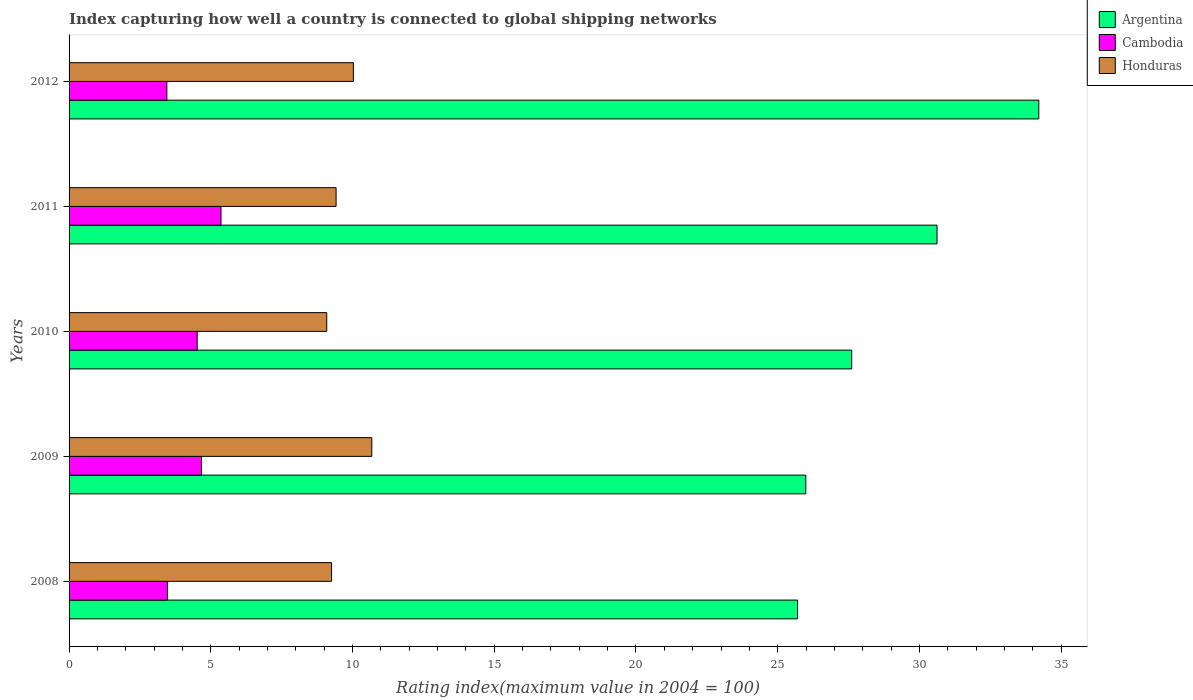Are the number of bars on each tick of the Y-axis equal?
Provide a succinct answer. Yes. How many bars are there on the 2nd tick from the top?
Your response must be concise. 3. What is the label of the 3rd group of bars from the top?
Provide a short and direct response. 2010. What is the rating index in Argentina in 2008?
Your response must be concise. 25.7. Across all years, what is the maximum rating index in Honduras?
Offer a very short reply. 10.68. Across all years, what is the minimum rating index in Honduras?
Keep it short and to the point. 9.09. What is the total rating index in Cambodia in the graph?
Offer a very short reply. 21.47. What is the difference between the rating index in Argentina in 2008 and that in 2010?
Make the answer very short. -1.91. What is the difference between the rating index in Argentina in 2010 and the rating index in Cambodia in 2009?
Give a very brief answer. 22.94. What is the average rating index in Cambodia per year?
Your answer should be very brief. 4.29. In the year 2009, what is the difference between the rating index in Cambodia and rating index in Honduras?
Provide a short and direct response. -6.01. In how many years, is the rating index in Argentina greater than 27 ?
Provide a short and direct response. 3. What is the ratio of the rating index in Honduras in 2009 to that in 2012?
Offer a very short reply. 1.06. What is the difference between the highest and the second highest rating index in Honduras?
Give a very brief answer. 0.65. What is the difference between the highest and the lowest rating index in Argentina?
Offer a terse response. 8.51. What does the 1st bar from the top in 2009 represents?
Provide a succinct answer. Honduras. How many bars are there?
Offer a terse response. 15. Are all the bars in the graph horizontal?
Provide a succinct answer. Yes. What is the difference between two consecutive major ticks on the X-axis?
Your response must be concise. 5. Does the graph contain grids?
Ensure brevity in your answer.  No. How many legend labels are there?
Your answer should be compact. 3. What is the title of the graph?
Your answer should be compact. Index capturing how well a country is connected to global shipping networks. What is the label or title of the X-axis?
Your answer should be compact. Rating index(maximum value in 2004 = 100). What is the Rating index(maximum value in 2004 = 100) of Argentina in 2008?
Your response must be concise. 25.7. What is the Rating index(maximum value in 2004 = 100) of Cambodia in 2008?
Offer a very short reply. 3.47. What is the Rating index(maximum value in 2004 = 100) of Honduras in 2008?
Offer a terse response. 9.26. What is the Rating index(maximum value in 2004 = 100) of Argentina in 2009?
Keep it short and to the point. 25.99. What is the Rating index(maximum value in 2004 = 100) of Cambodia in 2009?
Give a very brief answer. 4.67. What is the Rating index(maximum value in 2004 = 100) of Honduras in 2009?
Keep it short and to the point. 10.68. What is the Rating index(maximum value in 2004 = 100) in Argentina in 2010?
Your answer should be compact. 27.61. What is the Rating index(maximum value in 2004 = 100) of Cambodia in 2010?
Keep it short and to the point. 4.52. What is the Rating index(maximum value in 2004 = 100) of Honduras in 2010?
Give a very brief answer. 9.09. What is the Rating index(maximum value in 2004 = 100) of Argentina in 2011?
Your response must be concise. 30.62. What is the Rating index(maximum value in 2004 = 100) in Cambodia in 2011?
Your response must be concise. 5.36. What is the Rating index(maximum value in 2004 = 100) in Honduras in 2011?
Give a very brief answer. 9.42. What is the Rating index(maximum value in 2004 = 100) of Argentina in 2012?
Your answer should be compact. 34.21. What is the Rating index(maximum value in 2004 = 100) in Cambodia in 2012?
Your answer should be very brief. 3.45. What is the Rating index(maximum value in 2004 = 100) of Honduras in 2012?
Your response must be concise. 10.03. Across all years, what is the maximum Rating index(maximum value in 2004 = 100) in Argentina?
Make the answer very short. 34.21. Across all years, what is the maximum Rating index(maximum value in 2004 = 100) in Cambodia?
Keep it short and to the point. 5.36. Across all years, what is the maximum Rating index(maximum value in 2004 = 100) of Honduras?
Make the answer very short. 10.68. Across all years, what is the minimum Rating index(maximum value in 2004 = 100) in Argentina?
Your response must be concise. 25.7. Across all years, what is the minimum Rating index(maximum value in 2004 = 100) of Cambodia?
Offer a terse response. 3.45. Across all years, what is the minimum Rating index(maximum value in 2004 = 100) of Honduras?
Give a very brief answer. 9.09. What is the total Rating index(maximum value in 2004 = 100) of Argentina in the graph?
Provide a short and direct response. 144.13. What is the total Rating index(maximum value in 2004 = 100) of Cambodia in the graph?
Give a very brief answer. 21.47. What is the total Rating index(maximum value in 2004 = 100) in Honduras in the graph?
Offer a very short reply. 48.48. What is the difference between the Rating index(maximum value in 2004 = 100) of Argentina in 2008 and that in 2009?
Offer a very short reply. -0.29. What is the difference between the Rating index(maximum value in 2004 = 100) of Honduras in 2008 and that in 2009?
Keep it short and to the point. -1.42. What is the difference between the Rating index(maximum value in 2004 = 100) in Argentina in 2008 and that in 2010?
Your answer should be compact. -1.91. What is the difference between the Rating index(maximum value in 2004 = 100) in Cambodia in 2008 and that in 2010?
Offer a terse response. -1.05. What is the difference between the Rating index(maximum value in 2004 = 100) of Honduras in 2008 and that in 2010?
Give a very brief answer. 0.17. What is the difference between the Rating index(maximum value in 2004 = 100) of Argentina in 2008 and that in 2011?
Your answer should be very brief. -4.92. What is the difference between the Rating index(maximum value in 2004 = 100) in Cambodia in 2008 and that in 2011?
Your answer should be very brief. -1.89. What is the difference between the Rating index(maximum value in 2004 = 100) in Honduras in 2008 and that in 2011?
Offer a very short reply. -0.16. What is the difference between the Rating index(maximum value in 2004 = 100) of Argentina in 2008 and that in 2012?
Provide a short and direct response. -8.51. What is the difference between the Rating index(maximum value in 2004 = 100) of Cambodia in 2008 and that in 2012?
Give a very brief answer. 0.02. What is the difference between the Rating index(maximum value in 2004 = 100) of Honduras in 2008 and that in 2012?
Your answer should be compact. -0.77. What is the difference between the Rating index(maximum value in 2004 = 100) of Argentina in 2009 and that in 2010?
Provide a short and direct response. -1.62. What is the difference between the Rating index(maximum value in 2004 = 100) in Cambodia in 2009 and that in 2010?
Ensure brevity in your answer.  0.15. What is the difference between the Rating index(maximum value in 2004 = 100) in Honduras in 2009 and that in 2010?
Keep it short and to the point. 1.59. What is the difference between the Rating index(maximum value in 2004 = 100) of Argentina in 2009 and that in 2011?
Give a very brief answer. -4.63. What is the difference between the Rating index(maximum value in 2004 = 100) of Cambodia in 2009 and that in 2011?
Make the answer very short. -0.69. What is the difference between the Rating index(maximum value in 2004 = 100) of Honduras in 2009 and that in 2011?
Keep it short and to the point. 1.26. What is the difference between the Rating index(maximum value in 2004 = 100) in Argentina in 2009 and that in 2012?
Keep it short and to the point. -8.22. What is the difference between the Rating index(maximum value in 2004 = 100) in Cambodia in 2009 and that in 2012?
Make the answer very short. 1.22. What is the difference between the Rating index(maximum value in 2004 = 100) in Honduras in 2009 and that in 2012?
Provide a short and direct response. 0.65. What is the difference between the Rating index(maximum value in 2004 = 100) in Argentina in 2010 and that in 2011?
Provide a short and direct response. -3.01. What is the difference between the Rating index(maximum value in 2004 = 100) in Cambodia in 2010 and that in 2011?
Keep it short and to the point. -0.84. What is the difference between the Rating index(maximum value in 2004 = 100) of Honduras in 2010 and that in 2011?
Keep it short and to the point. -0.33. What is the difference between the Rating index(maximum value in 2004 = 100) in Cambodia in 2010 and that in 2012?
Keep it short and to the point. 1.07. What is the difference between the Rating index(maximum value in 2004 = 100) in Honduras in 2010 and that in 2012?
Provide a succinct answer. -0.94. What is the difference between the Rating index(maximum value in 2004 = 100) of Argentina in 2011 and that in 2012?
Make the answer very short. -3.59. What is the difference between the Rating index(maximum value in 2004 = 100) of Cambodia in 2011 and that in 2012?
Offer a terse response. 1.91. What is the difference between the Rating index(maximum value in 2004 = 100) of Honduras in 2011 and that in 2012?
Offer a very short reply. -0.61. What is the difference between the Rating index(maximum value in 2004 = 100) of Argentina in 2008 and the Rating index(maximum value in 2004 = 100) of Cambodia in 2009?
Give a very brief answer. 21.03. What is the difference between the Rating index(maximum value in 2004 = 100) of Argentina in 2008 and the Rating index(maximum value in 2004 = 100) of Honduras in 2009?
Make the answer very short. 15.02. What is the difference between the Rating index(maximum value in 2004 = 100) of Cambodia in 2008 and the Rating index(maximum value in 2004 = 100) of Honduras in 2009?
Provide a short and direct response. -7.21. What is the difference between the Rating index(maximum value in 2004 = 100) of Argentina in 2008 and the Rating index(maximum value in 2004 = 100) of Cambodia in 2010?
Your answer should be compact. 21.18. What is the difference between the Rating index(maximum value in 2004 = 100) of Argentina in 2008 and the Rating index(maximum value in 2004 = 100) of Honduras in 2010?
Offer a terse response. 16.61. What is the difference between the Rating index(maximum value in 2004 = 100) in Cambodia in 2008 and the Rating index(maximum value in 2004 = 100) in Honduras in 2010?
Your answer should be very brief. -5.62. What is the difference between the Rating index(maximum value in 2004 = 100) of Argentina in 2008 and the Rating index(maximum value in 2004 = 100) of Cambodia in 2011?
Offer a terse response. 20.34. What is the difference between the Rating index(maximum value in 2004 = 100) in Argentina in 2008 and the Rating index(maximum value in 2004 = 100) in Honduras in 2011?
Provide a succinct answer. 16.28. What is the difference between the Rating index(maximum value in 2004 = 100) in Cambodia in 2008 and the Rating index(maximum value in 2004 = 100) in Honduras in 2011?
Your response must be concise. -5.95. What is the difference between the Rating index(maximum value in 2004 = 100) in Argentina in 2008 and the Rating index(maximum value in 2004 = 100) in Cambodia in 2012?
Offer a terse response. 22.25. What is the difference between the Rating index(maximum value in 2004 = 100) in Argentina in 2008 and the Rating index(maximum value in 2004 = 100) in Honduras in 2012?
Your answer should be compact. 15.67. What is the difference between the Rating index(maximum value in 2004 = 100) of Cambodia in 2008 and the Rating index(maximum value in 2004 = 100) of Honduras in 2012?
Provide a short and direct response. -6.56. What is the difference between the Rating index(maximum value in 2004 = 100) in Argentina in 2009 and the Rating index(maximum value in 2004 = 100) in Cambodia in 2010?
Offer a very short reply. 21.47. What is the difference between the Rating index(maximum value in 2004 = 100) of Argentina in 2009 and the Rating index(maximum value in 2004 = 100) of Honduras in 2010?
Keep it short and to the point. 16.9. What is the difference between the Rating index(maximum value in 2004 = 100) of Cambodia in 2009 and the Rating index(maximum value in 2004 = 100) of Honduras in 2010?
Your answer should be compact. -4.42. What is the difference between the Rating index(maximum value in 2004 = 100) of Argentina in 2009 and the Rating index(maximum value in 2004 = 100) of Cambodia in 2011?
Provide a succinct answer. 20.63. What is the difference between the Rating index(maximum value in 2004 = 100) of Argentina in 2009 and the Rating index(maximum value in 2004 = 100) of Honduras in 2011?
Your answer should be compact. 16.57. What is the difference between the Rating index(maximum value in 2004 = 100) in Cambodia in 2009 and the Rating index(maximum value in 2004 = 100) in Honduras in 2011?
Offer a terse response. -4.75. What is the difference between the Rating index(maximum value in 2004 = 100) in Argentina in 2009 and the Rating index(maximum value in 2004 = 100) in Cambodia in 2012?
Ensure brevity in your answer.  22.54. What is the difference between the Rating index(maximum value in 2004 = 100) of Argentina in 2009 and the Rating index(maximum value in 2004 = 100) of Honduras in 2012?
Your response must be concise. 15.96. What is the difference between the Rating index(maximum value in 2004 = 100) in Cambodia in 2009 and the Rating index(maximum value in 2004 = 100) in Honduras in 2012?
Offer a terse response. -5.36. What is the difference between the Rating index(maximum value in 2004 = 100) in Argentina in 2010 and the Rating index(maximum value in 2004 = 100) in Cambodia in 2011?
Offer a terse response. 22.25. What is the difference between the Rating index(maximum value in 2004 = 100) of Argentina in 2010 and the Rating index(maximum value in 2004 = 100) of Honduras in 2011?
Your answer should be very brief. 18.19. What is the difference between the Rating index(maximum value in 2004 = 100) in Cambodia in 2010 and the Rating index(maximum value in 2004 = 100) in Honduras in 2011?
Your answer should be compact. -4.9. What is the difference between the Rating index(maximum value in 2004 = 100) in Argentina in 2010 and the Rating index(maximum value in 2004 = 100) in Cambodia in 2012?
Offer a terse response. 24.16. What is the difference between the Rating index(maximum value in 2004 = 100) in Argentina in 2010 and the Rating index(maximum value in 2004 = 100) in Honduras in 2012?
Make the answer very short. 17.58. What is the difference between the Rating index(maximum value in 2004 = 100) in Cambodia in 2010 and the Rating index(maximum value in 2004 = 100) in Honduras in 2012?
Keep it short and to the point. -5.51. What is the difference between the Rating index(maximum value in 2004 = 100) in Argentina in 2011 and the Rating index(maximum value in 2004 = 100) in Cambodia in 2012?
Provide a short and direct response. 27.17. What is the difference between the Rating index(maximum value in 2004 = 100) in Argentina in 2011 and the Rating index(maximum value in 2004 = 100) in Honduras in 2012?
Keep it short and to the point. 20.59. What is the difference between the Rating index(maximum value in 2004 = 100) in Cambodia in 2011 and the Rating index(maximum value in 2004 = 100) in Honduras in 2012?
Ensure brevity in your answer.  -4.67. What is the average Rating index(maximum value in 2004 = 100) of Argentina per year?
Make the answer very short. 28.83. What is the average Rating index(maximum value in 2004 = 100) of Cambodia per year?
Your answer should be very brief. 4.29. What is the average Rating index(maximum value in 2004 = 100) in Honduras per year?
Offer a very short reply. 9.7. In the year 2008, what is the difference between the Rating index(maximum value in 2004 = 100) in Argentina and Rating index(maximum value in 2004 = 100) in Cambodia?
Offer a very short reply. 22.23. In the year 2008, what is the difference between the Rating index(maximum value in 2004 = 100) in Argentina and Rating index(maximum value in 2004 = 100) in Honduras?
Make the answer very short. 16.44. In the year 2008, what is the difference between the Rating index(maximum value in 2004 = 100) in Cambodia and Rating index(maximum value in 2004 = 100) in Honduras?
Offer a very short reply. -5.79. In the year 2009, what is the difference between the Rating index(maximum value in 2004 = 100) of Argentina and Rating index(maximum value in 2004 = 100) of Cambodia?
Make the answer very short. 21.32. In the year 2009, what is the difference between the Rating index(maximum value in 2004 = 100) in Argentina and Rating index(maximum value in 2004 = 100) in Honduras?
Make the answer very short. 15.31. In the year 2009, what is the difference between the Rating index(maximum value in 2004 = 100) in Cambodia and Rating index(maximum value in 2004 = 100) in Honduras?
Provide a short and direct response. -6.01. In the year 2010, what is the difference between the Rating index(maximum value in 2004 = 100) in Argentina and Rating index(maximum value in 2004 = 100) in Cambodia?
Provide a short and direct response. 23.09. In the year 2010, what is the difference between the Rating index(maximum value in 2004 = 100) in Argentina and Rating index(maximum value in 2004 = 100) in Honduras?
Ensure brevity in your answer.  18.52. In the year 2010, what is the difference between the Rating index(maximum value in 2004 = 100) in Cambodia and Rating index(maximum value in 2004 = 100) in Honduras?
Keep it short and to the point. -4.57. In the year 2011, what is the difference between the Rating index(maximum value in 2004 = 100) in Argentina and Rating index(maximum value in 2004 = 100) in Cambodia?
Your response must be concise. 25.26. In the year 2011, what is the difference between the Rating index(maximum value in 2004 = 100) in Argentina and Rating index(maximum value in 2004 = 100) in Honduras?
Keep it short and to the point. 21.2. In the year 2011, what is the difference between the Rating index(maximum value in 2004 = 100) in Cambodia and Rating index(maximum value in 2004 = 100) in Honduras?
Make the answer very short. -4.06. In the year 2012, what is the difference between the Rating index(maximum value in 2004 = 100) in Argentina and Rating index(maximum value in 2004 = 100) in Cambodia?
Your answer should be very brief. 30.76. In the year 2012, what is the difference between the Rating index(maximum value in 2004 = 100) in Argentina and Rating index(maximum value in 2004 = 100) in Honduras?
Keep it short and to the point. 24.18. In the year 2012, what is the difference between the Rating index(maximum value in 2004 = 100) in Cambodia and Rating index(maximum value in 2004 = 100) in Honduras?
Ensure brevity in your answer.  -6.58. What is the ratio of the Rating index(maximum value in 2004 = 100) of Argentina in 2008 to that in 2009?
Your response must be concise. 0.99. What is the ratio of the Rating index(maximum value in 2004 = 100) in Cambodia in 2008 to that in 2009?
Make the answer very short. 0.74. What is the ratio of the Rating index(maximum value in 2004 = 100) in Honduras in 2008 to that in 2009?
Give a very brief answer. 0.87. What is the ratio of the Rating index(maximum value in 2004 = 100) in Argentina in 2008 to that in 2010?
Provide a short and direct response. 0.93. What is the ratio of the Rating index(maximum value in 2004 = 100) of Cambodia in 2008 to that in 2010?
Provide a short and direct response. 0.77. What is the ratio of the Rating index(maximum value in 2004 = 100) of Honduras in 2008 to that in 2010?
Make the answer very short. 1.02. What is the ratio of the Rating index(maximum value in 2004 = 100) of Argentina in 2008 to that in 2011?
Ensure brevity in your answer.  0.84. What is the ratio of the Rating index(maximum value in 2004 = 100) of Cambodia in 2008 to that in 2011?
Provide a short and direct response. 0.65. What is the ratio of the Rating index(maximum value in 2004 = 100) in Argentina in 2008 to that in 2012?
Offer a terse response. 0.75. What is the ratio of the Rating index(maximum value in 2004 = 100) in Cambodia in 2008 to that in 2012?
Offer a terse response. 1.01. What is the ratio of the Rating index(maximum value in 2004 = 100) of Honduras in 2008 to that in 2012?
Your response must be concise. 0.92. What is the ratio of the Rating index(maximum value in 2004 = 100) of Argentina in 2009 to that in 2010?
Your answer should be very brief. 0.94. What is the ratio of the Rating index(maximum value in 2004 = 100) in Cambodia in 2009 to that in 2010?
Make the answer very short. 1.03. What is the ratio of the Rating index(maximum value in 2004 = 100) in Honduras in 2009 to that in 2010?
Your answer should be very brief. 1.17. What is the ratio of the Rating index(maximum value in 2004 = 100) of Argentina in 2009 to that in 2011?
Ensure brevity in your answer.  0.85. What is the ratio of the Rating index(maximum value in 2004 = 100) of Cambodia in 2009 to that in 2011?
Give a very brief answer. 0.87. What is the ratio of the Rating index(maximum value in 2004 = 100) of Honduras in 2009 to that in 2011?
Keep it short and to the point. 1.13. What is the ratio of the Rating index(maximum value in 2004 = 100) of Argentina in 2009 to that in 2012?
Keep it short and to the point. 0.76. What is the ratio of the Rating index(maximum value in 2004 = 100) of Cambodia in 2009 to that in 2012?
Your answer should be very brief. 1.35. What is the ratio of the Rating index(maximum value in 2004 = 100) of Honduras in 2009 to that in 2012?
Provide a short and direct response. 1.06. What is the ratio of the Rating index(maximum value in 2004 = 100) of Argentina in 2010 to that in 2011?
Your answer should be compact. 0.9. What is the ratio of the Rating index(maximum value in 2004 = 100) of Cambodia in 2010 to that in 2011?
Provide a short and direct response. 0.84. What is the ratio of the Rating index(maximum value in 2004 = 100) in Honduras in 2010 to that in 2011?
Make the answer very short. 0.96. What is the ratio of the Rating index(maximum value in 2004 = 100) in Argentina in 2010 to that in 2012?
Provide a succinct answer. 0.81. What is the ratio of the Rating index(maximum value in 2004 = 100) of Cambodia in 2010 to that in 2012?
Your response must be concise. 1.31. What is the ratio of the Rating index(maximum value in 2004 = 100) of Honduras in 2010 to that in 2012?
Offer a terse response. 0.91. What is the ratio of the Rating index(maximum value in 2004 = 100) in Argentina in 2011 to that in 2012?
Your answer should be very brief. 0.9. What is the ratio of the Rating index(maximum value in 2004 = 100) of Cambodia in 2011 to that in 2012?
Your answer should be compact. 1.55. What is the ratio of the Rating index(maximum value in 2004 = 100) in Honduras in 2011 to that in 2012?
Keep it short and to the point. 0.94. What is the difference between the highest and the second highest Rating index(maximum value in 2004 = 100) of Argentina?
Give a very brief answer. 3.59. What is the difference between the highest and the second highest Rating index(maximum value in 2004 = 100) in Cambodia?
Give a very brief answer. 0.69. What is the difference between the highest and the second highest Rating index(maximum value in 2004 = 100) in Honduras?
Your response must be concise. 0.65. What is the difference between the highest and the lowest Rating index(maximum value in 2004 = 100) of Argentina?
Provide a short and direct response. 8.51. What is the difference between the highest and the lowest Rating index(maximum value in 2004 = 100) of Cambodia?
Keep it short and to the point. 1.91. What is the difference between the highest and the lowest Rating index(maximum value in 2004 = 100) of Honduras?
Offer a terse response. 1.59. 